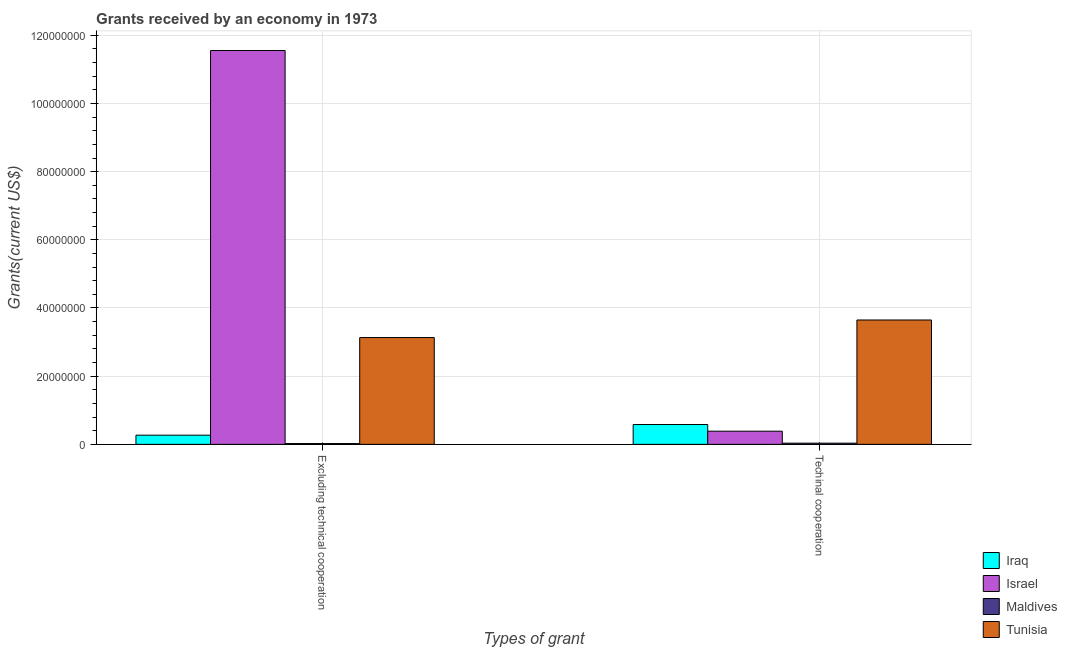How many different coloured bars are there?
Keep it short and to the point. 4. Are the number of bars per tick equal to the number of legend labels?
Make the answer very short. Yes. How many bars are there on the 2nd tick from the left?
Your answer should be compact. 4. What is the label of the 2nd group of bars from the left?
Your response must be concise. Techinal cooperation. What is the amount of grants received(including technical cooperation) in Iraq?
Provide a short and direct response. 5.82e+06. Across all countries, what is the maximum amount of grants received(excluding technical cooperation)?
Offer a very short reply. 1.16e+08. Across all countries, what is the minimum amount of grants received(including technical cooperation)?
Offer a terse response. 3.50e+05. In which country was the amount of grants received(excluding technical cooperation) minimum?
Your answer should be very brief. Maldives. What is the total amount of grants received(excluding technical cooperation) in the graph?
Make the answer very short. 1.50e+08. What is the difference between the amount of grants received(including technical cooperation) in Israel and that in Tunisia?
Keep it short and to the point. -3.26e+07. What is the difference between the amount of grants received(including technical cooperation) in Tunisia and the amount of grants received(excluding technical cooperation) in Iraq?
Provide a short and direct response. 3.38e+07. What is the average amount of grants received(including technical cooperation) per country?
Your response must be concise. 1.16e+07. What is the difference between the amount of grants received(excluding technical cooperation) and amount of grants received(including technical cooperation) in Maldives?
Give a very brief answer. -1.20e+05. In how many countries, is the amount of grants received(excluding technical cooperation) greater than 76000000 US$?
Offer a very short reply. 1. What is the ratio of the amount of grants received(including technical cooperation) in Israel to that in Maldives?
Keep it short and to the point. 11.03. Is the amount of grants received(excluding technical cooperation) in Maldives less than that in Tunisia?
Offer a terse response. Yes. What does the 1st bar from the left in Techinal cooperation represents?
Your response must be concise. Iraq. How many bars are there?
Offer a terse response. 8. What is the difference between two consecutive major ticks on the Y-axis?
Your answer should be compact. 2.00e+07. Are the values on the major ticks of Y-axis written in scientific E-notation?
Your answer should be very brief. No. Does the graph contain any zero values?
Your answer should be very brief. No. Does the graph contain grids?
Give a very brief answer. Yes. Where does the legend appear in the graph?
Offer a terse response. Bottom right. How many legend labels are there?
Offer a terse response. 4. How are the legend labels stacked?
Provide a succinct answer. Vertical. What is the title of the graph?
Your response must be concise. Grants received by an economy in 1973. Does "Dominica" appear as one of the legend labels in the graph?
Make the answer very short. No. What is the label or title of the X-axis?
Offer a terse response. Types of grant. What is the label or title of the Y-axis?
Provide a short and direct response. Grants(current US$). What is the Grants(current US$) of Iraq in Excluding technical cooperation?
Your answer should be very brief. 2.69e+06. What is the Grants(current US$) of Israel in Excluding technical cooperation?
Give a very brief answer. 1.16e+08. What is the Grants(current US$) of Maldives in Excluding technical cooperation?
Make the answer very short. 2.30e+05. What is the Grants(current US$) of Tunisia in Excluding technical cooperation?
Your response must be concise. 3.13e+07. What is the Grants(current US$) of Iraq in Techinal cooperation?
Your response must be concise. 5.82e+06. What is the Grants(current US$) in Israel in Techinal cooperation?
Your response must be concise. 3.86e+06. What is the Grants(current US$) in Tunisia in Techinal cooperation?
Your answer should be compact. 3.65e+07. Across all Types of grant, what is the maximum Grants(current US$) in Iraq?
Ensure brevity in your answer.  5.82e+06. Across all Types of grant, what is the maximum Grants(current US$) in Israel?
Your response must be concise. 1.16e+08. Across all Types of grant, what is the maximum Grants(current US$) of Tunisia?
Your response must be concise. 3.65e+07. Across all Types of grant, what is the minimum Grants(current US$) in Iraq?
Your answer should be compact. 2.69e+06. Across all Types of grant, what is the minimum Grants(current US$) in Israel?
Ensure brevity in your answer.  3.86e+06. Across all Types of grant, what is the minimum Grants(current US$) of Tunisia?
Provide a short and direct response. 3.13e+07. What is the total Grants(current US$) of Iraq in the graph?
Your answer should be very brief. 8.51e+06. What is the total Grants(current US$) in Israel in the graph?
Provide a succinct answer. 1.19e+08. What is the total Grants(current US$) in Maldives in the graph?
Give a very brief answer. 5.80e+05. What is the total Grants(current US$) of Tunisia in the graph?
Your answer should be very brief. 6.78e+07. What is the difference between the Grants(current US$) in Iraq in Excluding technical cooperation and that in Techinal cooperation?
Your answer should be compact. -3.13e+06. What is the difference between the Grants(current US$) in Israel in Excluding technical cooperation and that in Techinal cooperation?
Ensure brevity in your answer.  1.12e+08. What is the difference between the Grants(current US$) in Maldives in Excluding technical cooperation and that in Techinal cooperation?
Give a very brief answer. -1.20e+05. What is the difference between the Grants(current US$) in Tunisia in Excluding technical cooperation and that in Techinal cooperation?
Ensure brevity in your answer.  -5.15e+06. What is the difference between the Grants(current US$) of Iraq in Excluding technical cooperation and the Grants(current US$) of Israel in Techinal cooperation?
Offer a very short reply. -1.17e+06. What is the difference between the Grants(current US$) in Iraq in Excluding technical cooperation and the Grants(current US$) in Maldives in Techinal cooperation?
Your answer should be compact. 2.34e+06. What is the difference between the Grants(current US$) of Iraq in Excluding technical cooperation and the Grants(current US$) of Tunisia in Techinal cooperation?
Provide a succinct answer. -3.38e+07. What is the difference between the Grants(current US$) of Israel in Excluding technical cooperation and the Grants(current US$) of Maldives in Techinal cooperation?
Keep it short and to the point. 1.15e+08. What is the difference between the Grants(current US$) in Israel in Excluding technical cooperation and the Grants(current US$) in Tunisia in Techinal cooperation?
Your response must be concise. 7.90e+07. What is the difference between the Grants(current US$) of Maldives in Excluding technical cooperation and the Grants(current US$) of Tunisia in Techinal cooperation?
Give a very brief answer. -3.62e+07. What is the average Grants(current US$) of Iraq per Types of grant?
Provide a succinct answer. 4.26e+06. What is the average Grants(current US$) of Israel per Types of grant?
Provide a succinct answer. 5.97e+07. What is the average Grants(current US$) in Tunisia per Types of grant?
Offer a very short reply. 3.39e+07. What is the difference between the Grants(current US$) in Iraq and Grants(current US$) in Israel in Excluding technical cooperation?
Provide a short and direct response. -1.13e+08. What is the difference between the Grants(current US$) in Iraq and Grants(current US$) in Maldives in Excluding technical cooperation?
Your answer should be very brief. 2.46e+06. What is the difference between the Grants(current US$) of Iraq and Grants(current US$) of Tunisia in Excluding technical cooperation?
Offer a very short reply. -2.86e+07. What is the difference between the Grants(current US$) in Israel and Grants(current US$) in Maldives in Excluding technical cooperation?
Provide a succinct answer. 1.15e+08. What is the difference between the Grants(current US$) of Israel and Grants(current US$) of Tunisia in Excluding technical cooperation?
Give a very brief answer. 8.42e+07. What is the difference between the Grants(current US$) of Maldives and Grants(current US$) of Tunisia in Excluding technical cooperation?
Ensure brevity in your answer.  -3.11e+07. What is the difference between the Grants(current US$) in Iraq and Grants(current US$) in Israel in Techinal cooperation?
Your answer should be very brief. 1.96e+06. What is the difference between the Grants(current US$) in Iraq and Grants(current US$) in Maldives in Techinal cooperation?
Your response must be concise. 5.47e+06. What is the difference between the Grants(current US$) of Iraq and Grants(current US$) of Tunisia in Techinal cooperation?
Make the answer very short. -3.07e+07. What is the difference between the Grants(current US$) of Israel and Grants(current US$) of Maldives in Techinal cooperation?
Ensure brevity in your answer.  3.51e+06. What is the difference between the Grants(current US$) of Israel and Grants(current US$) of Tunisia in Techinal cooperation?
Provide a short and direct response. -3.26e+07. What is the difference between the Grants(current US$) in Maldives and Grants(current US$) in Tunisia in Techinal cooperation?
Your answer should be compact. -3.61e+07. What is the ratio of the Grants(current US$) in Iraq in Excluding technical cooperation to that in Techinal cooperation?
Your answer should be very brief. 0.46. What is the ratio of the Grants(current US$) of Israel in Excluding technical cooperation to that in Techinal cooperation?
Ensure brevity in your answer.  29.93. What is the ratio of the Grants(current US$) in Maldives in Excluding technical cooperation to that in Techinal cooperation?
Make the answer very short. 0.66. What is the ratio of the Grants(current US$) of Tunisia in Excluding technical cooperation to that in Techinal cooperation?
Make the answer very short. 0.86. What is the difference between the highest and the second highest Grants(current US$) in Iraq?
Provide a succinct answer. 3.13e+06. What is the difference between the highest and the second highest Grants(current US$) in Israel?
Keep it short and to the point. 1.12e+08. What is the difference between the highest and the second highest Grants(current US$) of Maldives?
Ensure brevity in your answer.  1.20e+05. What is the difference between the highest and the second highest Grants(current US$) of Tunisia?
Keep it short and to the point. 5.15e+06. What is the difference between the highest and the lowest Grants(current US$) in Iraq?
Your answer should be compact. 3.13e+06. What is the difference between the highest and the lowest Grants(current US$) of Israel?
Offer a very short reply. 1.12e+08. What is the difference between the highest and the lowest Grants(current US$) in Tunisia?
Make the answer very short. 5.15e+06. 